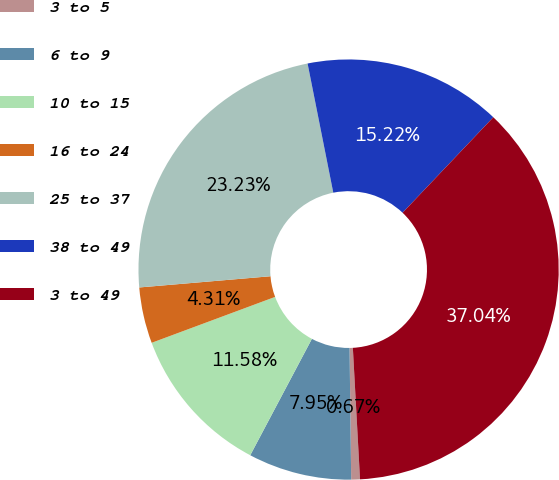Convert chart to OTSL. <chart><loc_0><loc_0><loc_500><loc_500><pie_chart><fcel>3 to 5<fcel>6 to 9<fcel>10 to 15<fcel>16 to 24<fcel>25 to 37<fcel>38 to 49<fcel>3 to 49<nl><fcel>0.67%<fcel>7.95%<fcel>11.58%<fcel>4.31%<fcel>23.23%<fcel>15.22%<fcel>37.04%<nl></chart> 